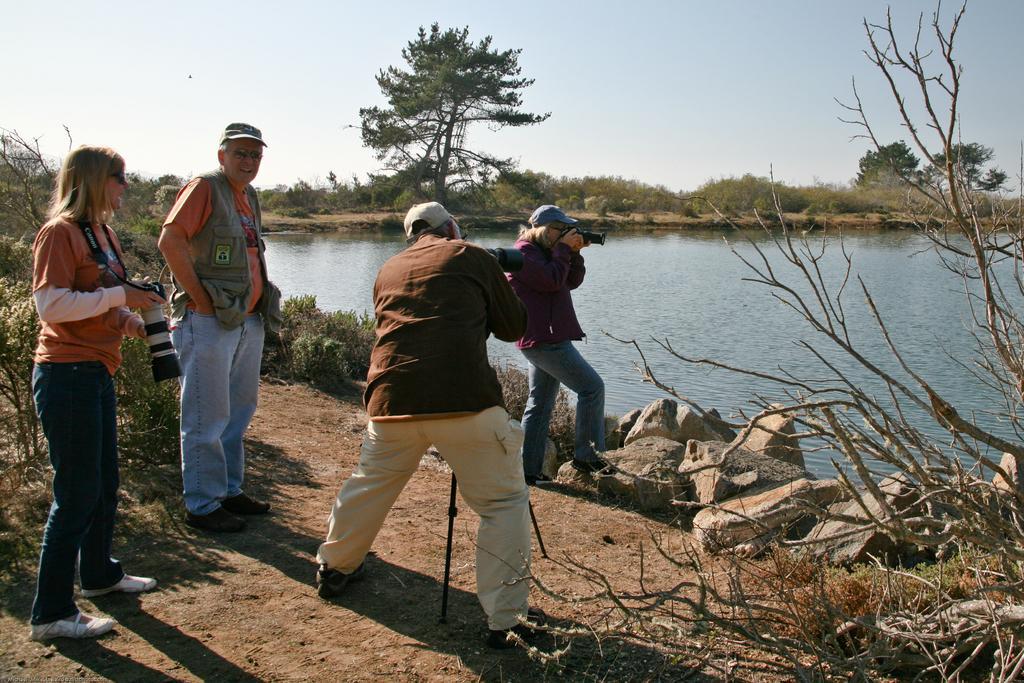In one or two sentences, can you explain what this image depicts? In this image we can see a few people, among them some holding the cameras, there are some trees, stones, water and plants, in the background, we can see the sky. 